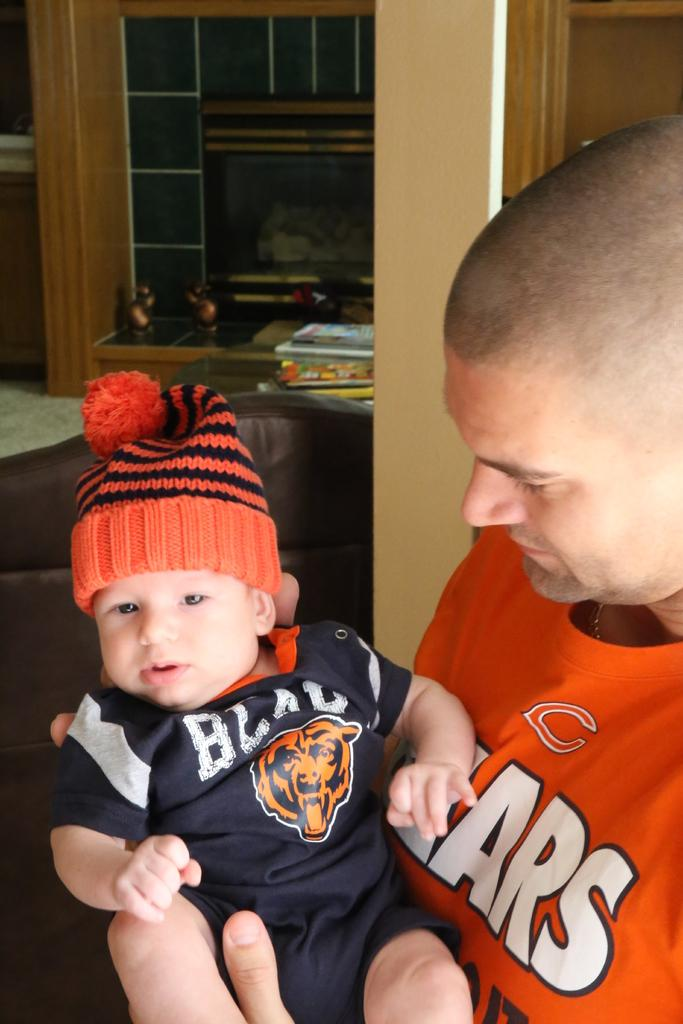What is the man in the image doing? The man is holding a baby in the image. What is the man wearing in the image? The man is wearing an orange t-shirt in the image. What is the baby wearing in the image? The baby is wearing a black t-shirt and an orange cap in the image. What type of map can be seen on the baby's collar in the image? There is no map or collar present on the baby in the image. 